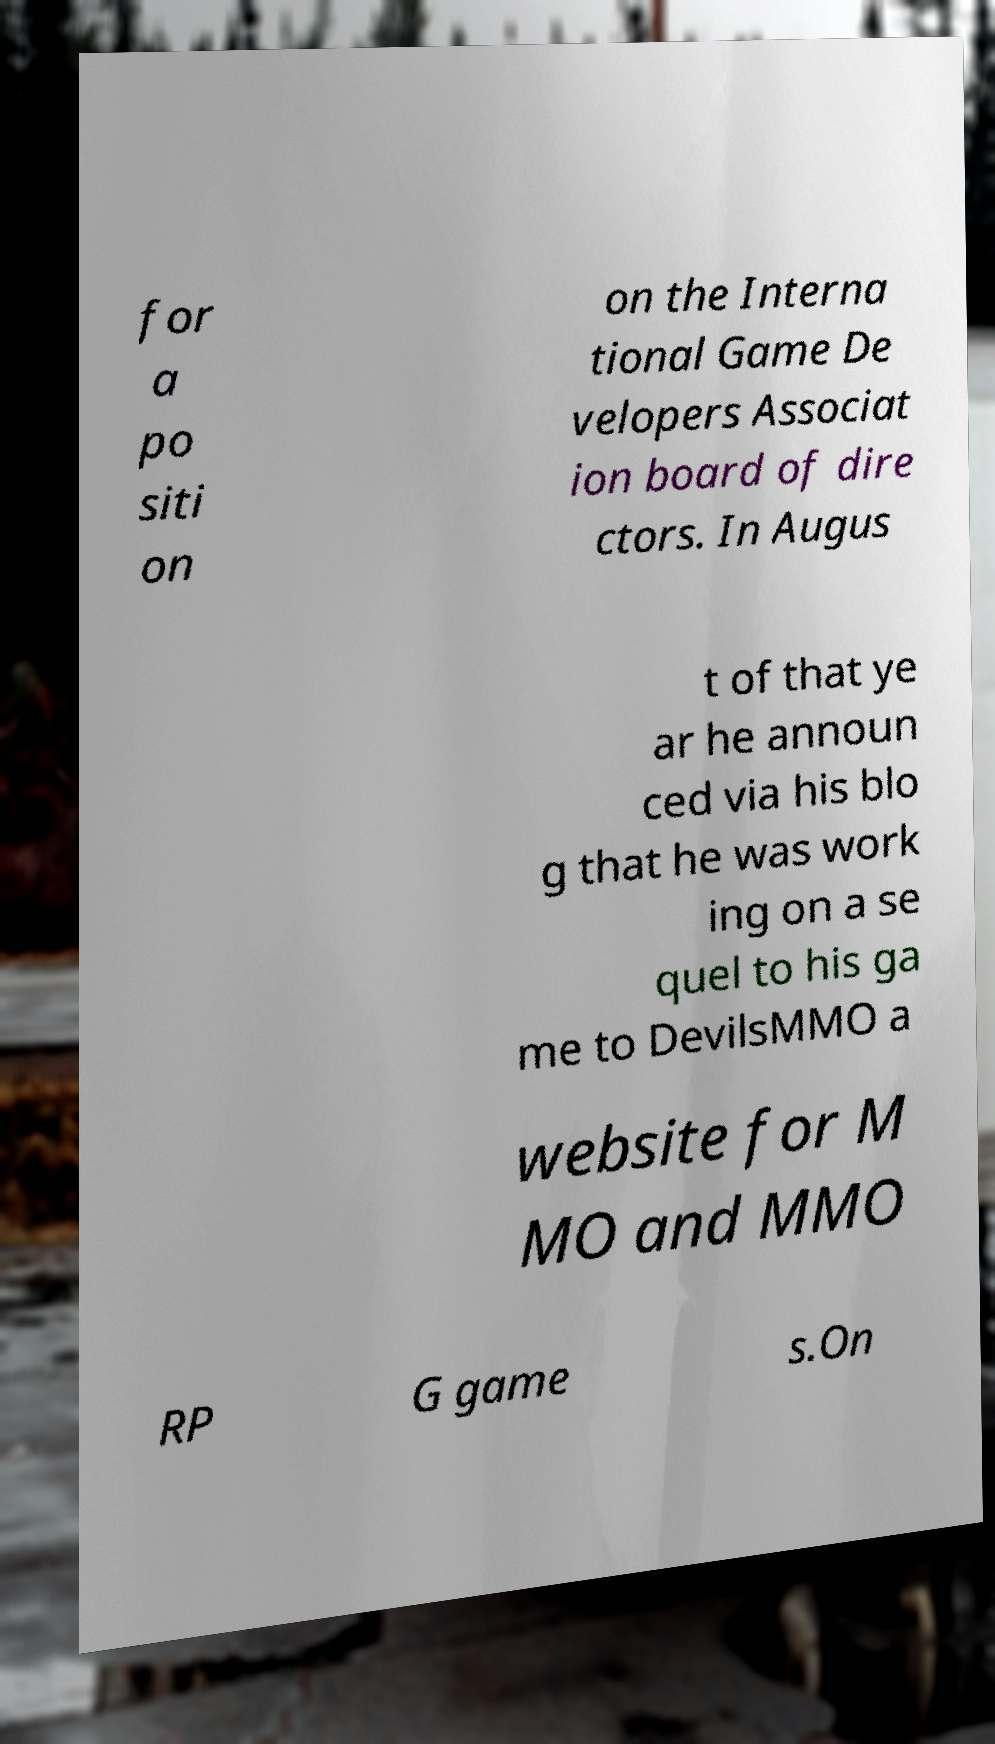What messages or text are displayed in this image? I need them in a readable, typed format. for a po siti on on the Interna tional Game De velopers Associat ion board of dire ctors. In Augus t of that ye ar he announ ced via his blo g that he was work ing on a se quel to his ga me to DevilsMMO a website for M MO and MMO RP G game s.On 